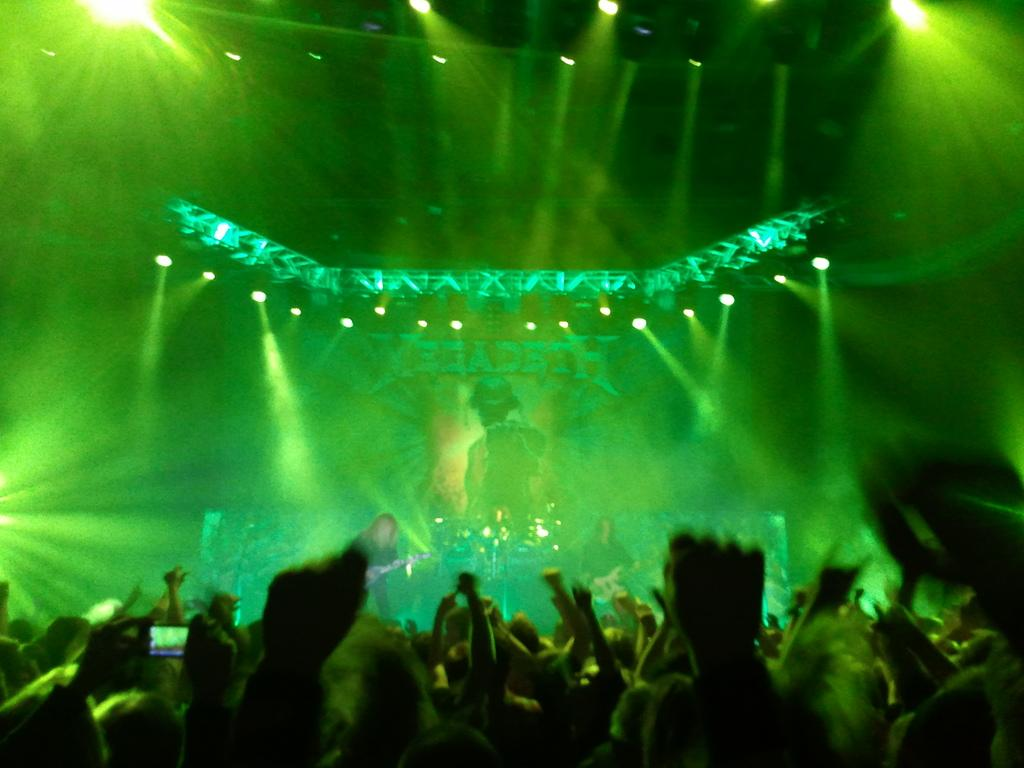What are the people in the image doing? The people in the image are dancing. Are there any musicians in the image? Yes, there are two persons playing musical instruments in the image. What can be seen in the background of the image? There are spotlights in the background of the image. Where is the hen located in the image? There is no hen present in the image. What type of store can be seen in the background of the image? There is no store visible in the image; it features people dancing and musicians playing instruments, with spotlights in the background. 